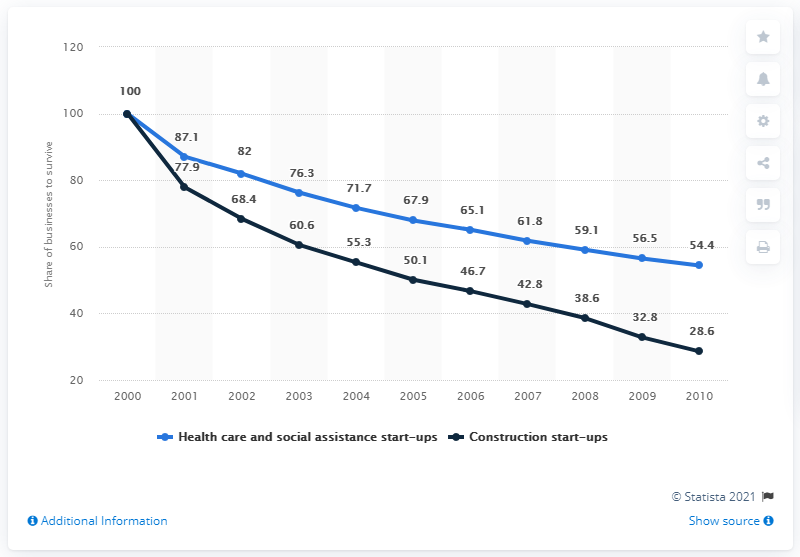What can be inferred about the overall trend for new business start-ups in these sectors based on the graph? The graph indicates a general decline in the share of new business start-ups in both the healthcare and social assistance sector and the construction sector from 2000 to 2010. This trend can reflect various factors such as market saturation, economic conditions, or changing industry dynamics that affected both sectors during this particular decade. 